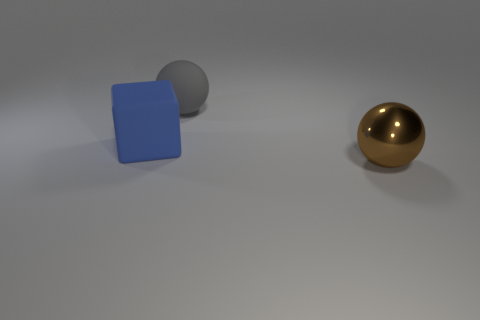Add 2 large cubes. How many objects exist? 5 Subtract all spheres. How many objects are left? 1 Add 1 big blue matte blocks. How many big blue matte blocks are left? 2 Add 3 big metallic objects. How many big metallic objects exist? 4 Subtract 0 cyan balls. How many objects are left? 3 Subtract all large blue rubber cubes. Subtract all gray matte balls. How many objects are left? 1 